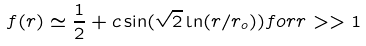<formula> <loc_0><loc_0><loc_500><loc_500>f ( r ) \simeq \frac { 1 } { 2 } + c \sin ( \sqrt { 2 } \ln ( r / r _ { o } ) ) f o r r > > 1</formula> 